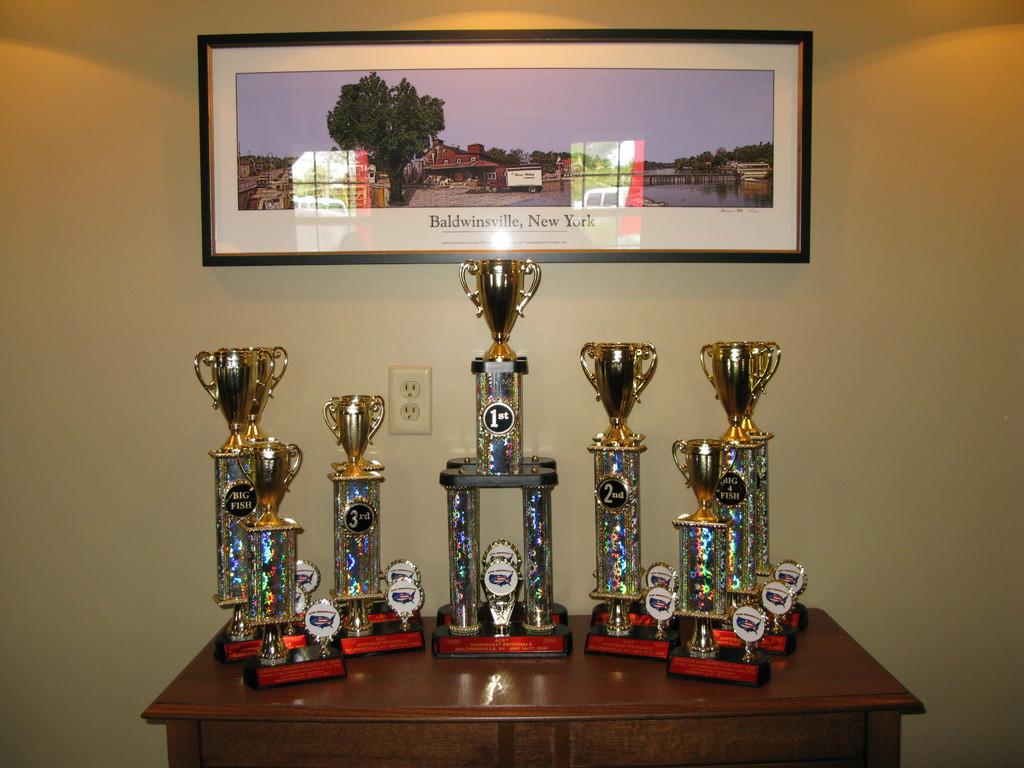What is the picture of?
Offer a terse response. Baldwinsville, new york. 